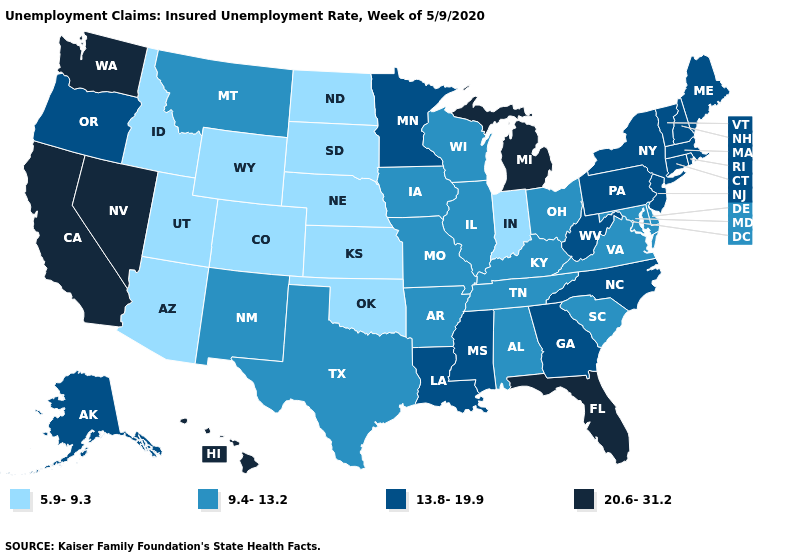Does California have the highest value in the USA?
Quick response, please. Yes. What is the lowest value in the Northeast?
Be succinct. 13.8-19.9. What is the highest value in the MidWest ?
Keep it brief. 20.6-31.2. Does Indiana have the highest value in the USA?
Short answer required. No. Does Michigan have the highest value in the MidWest?
Quick response, please. Yes. What is the highest value in states that border New Mexico?
Be succinct. 9.4-13.2. Does Hawaii have a lower value than South Carolina?
Quick response, please. No. Name the states that have a value in the range 13.8-19.9?
Quick response, please. Alaska, Connecticut, Georgia, Louisiana, Maine, Massachusetts, Minnesota, Mississippi, New Hampshire, New Jersey, New York, North Carolina, Oregon, Pennsylvania, Rhode Island, Vermont, West Virginia. Is the legend a continuous bar?
Be succinct. No. Which states have the highest value in the USA?
Keep it brief. California, Florida, Hawaii, Michigan, Nevada, Washington. Name the states that have a value in the range 9.4-13.2?
Write a very short answer. Alabama, Arkansas, Delaware, Illinois, Iowa, Kentucky, Maryland, Missouri, Montana, New Mexico, Ohio, South Carolina, Tennessee, Texas, Virginia, Wisconsin. What is the value of West Virginia?
Quick response, please. 13.8-19.9. Which states hav the highest value in the West?
Keep it brief. California, Hawaii, Nevada, Washington. Does Virginia have the lowest value in the South?
Write a very short answer. No. What is the value of Nebraska?
Give a very brief answer. 5.9-9.3. 